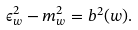<formula> <loc_0><loc_0><loc_500><loc_500>\epsilon _ { w } ^ { 2 } - m _ { w } ^ { 2 } = b ^ { 2 } ( w ) .</formula> 